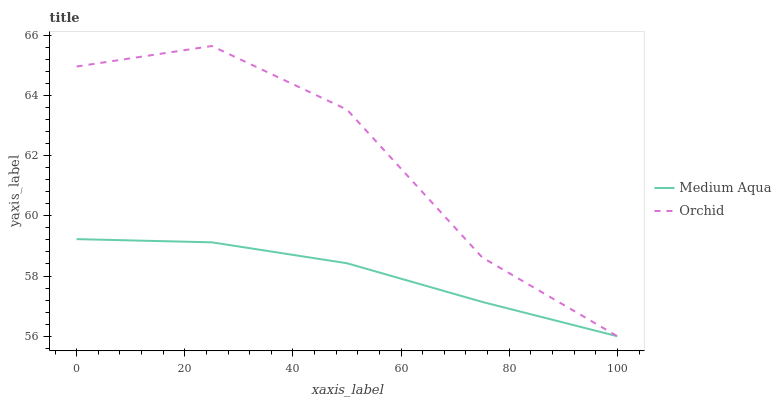Does Orchid have the minimum area under the curve?
Answer yes or no. No. Is Orchid the smoothest?
Answer yes or no. No. 